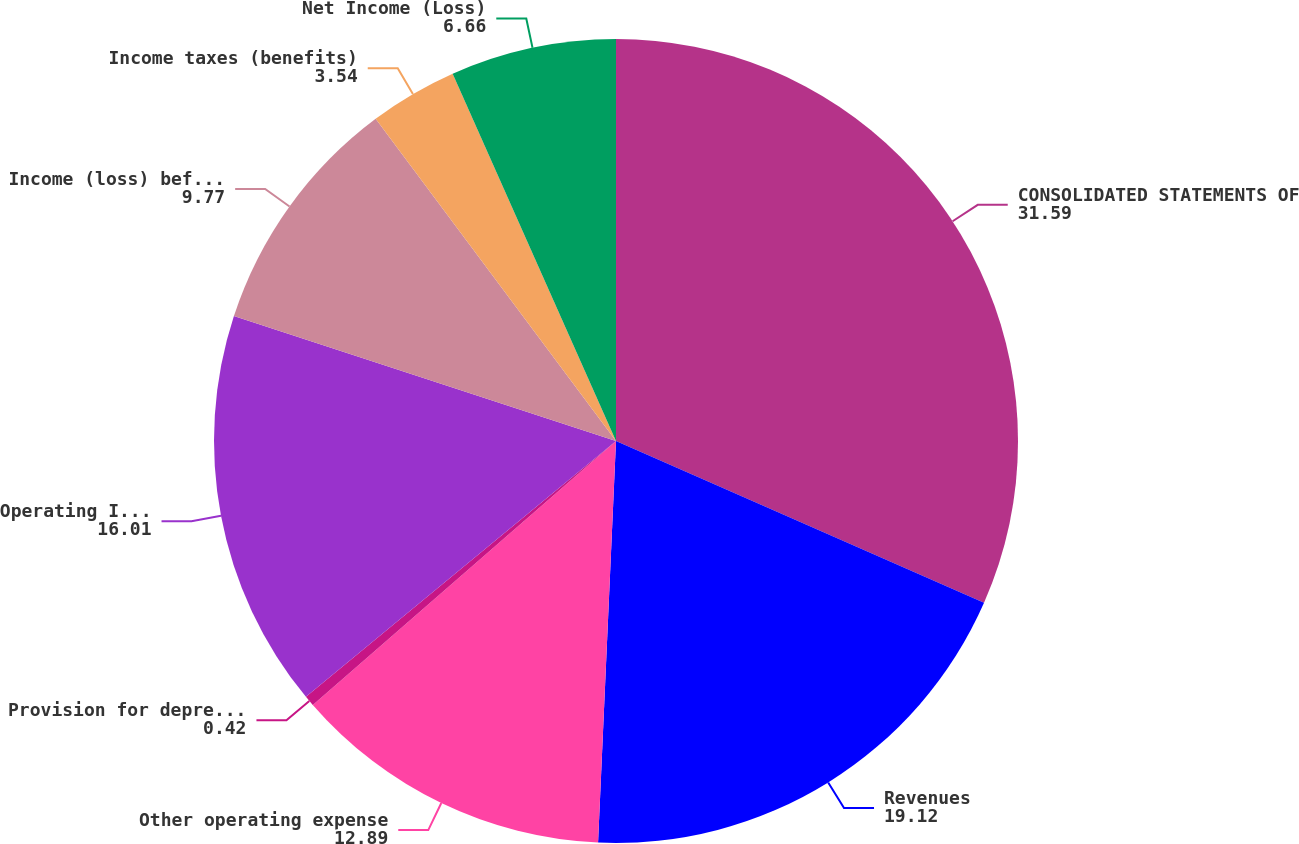Convert chart to OTSL. <chart><loc_0><loc_0><loc_500><loc_500><pie_chart><fcel>CONSOLIDATED STATEMENTS OF<fcel>Revenues<fcel>Other operating expense<fcel>Provision for depreciation<fcel>Operating Income (Loss)<fcel>Income (loss) before income<fcel>Income taxes (benefits)<fcel>Net Income (Loss)<nl><fcel>31.59%<fcel>19.12%<fcel>12.89%<fcel>0.42%<fcel>16.01%<fcel>9.77%<fcel>3.54%<fcel>6.66%<nl></chart> 